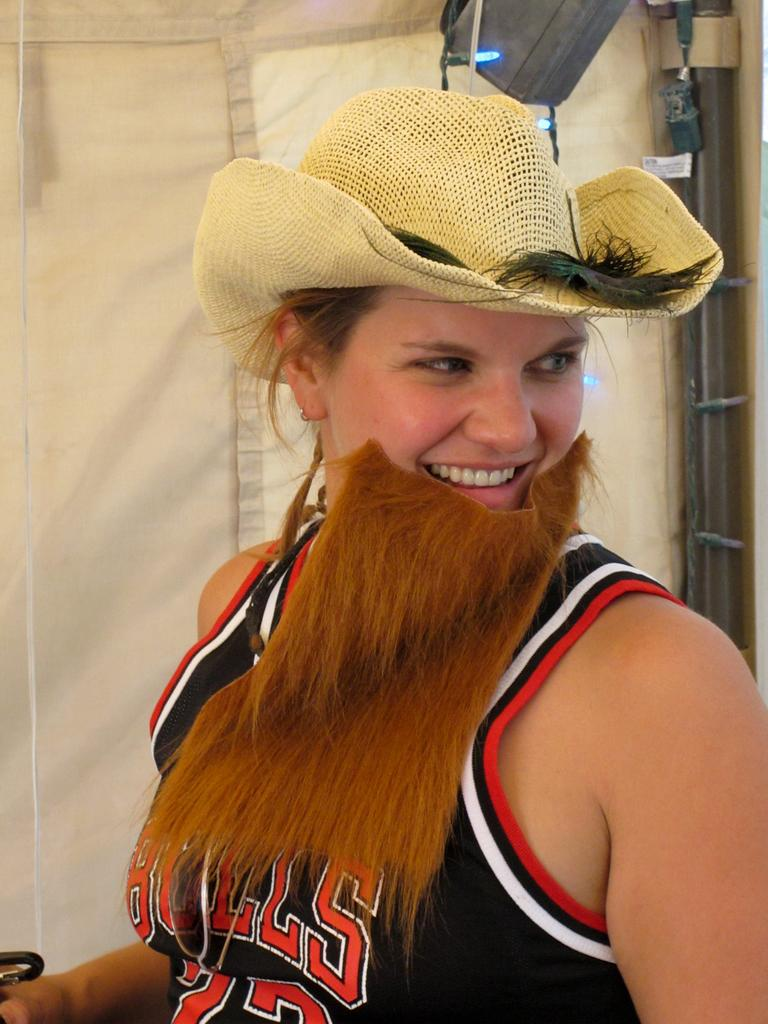<image>
Render a clear and concise summary of the photo. a girl wearing a fake beard and hat wearing a bulls tanktop 